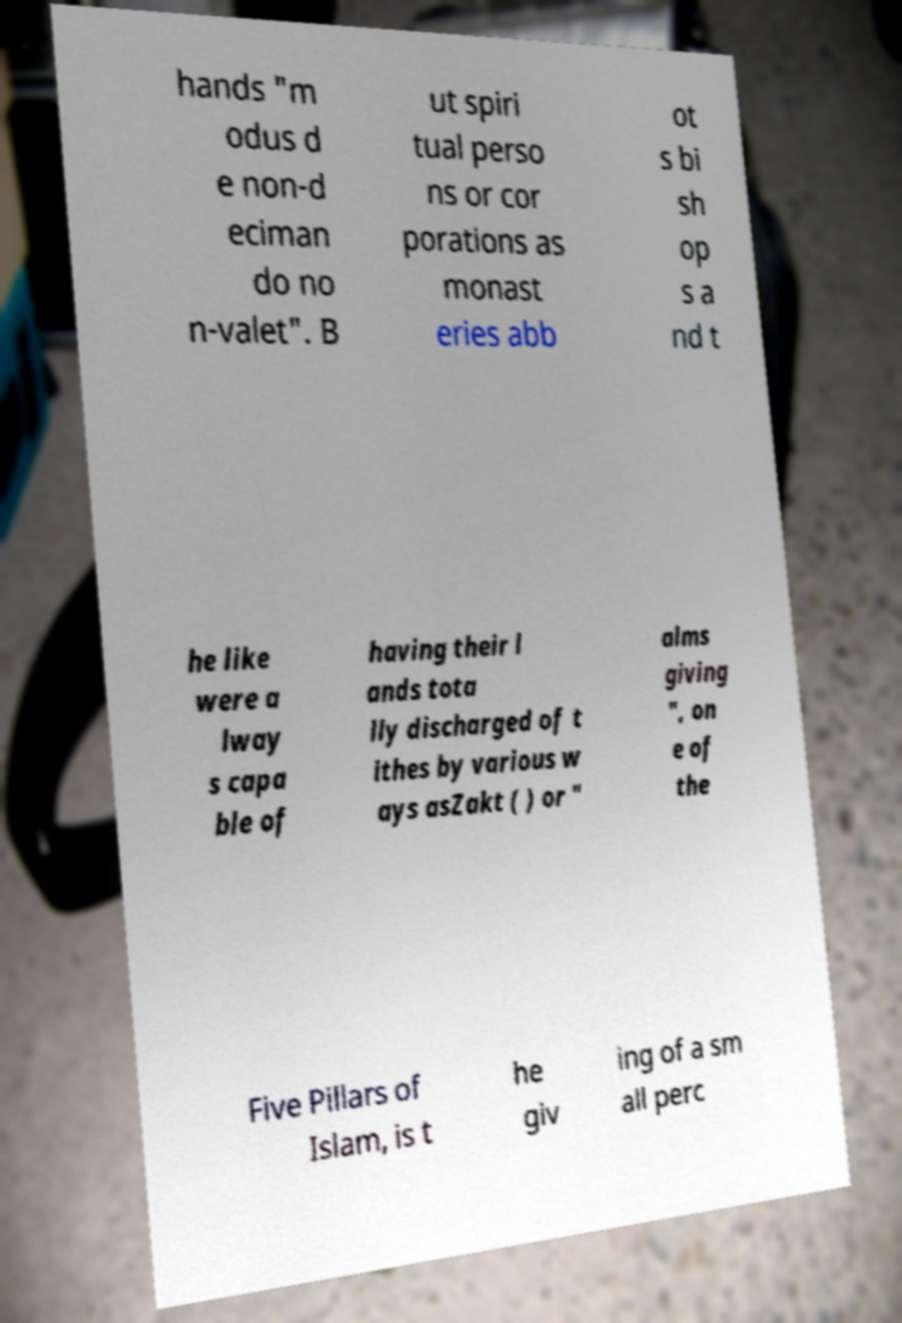Could you extract and type out the text from this image? hands "m odus d e non-d eciman do no n-valet". B ut spiri tual perso ns or cor porations as monast eries abb ot s bi sh op s a nd t he like were a lway s capa ble of having their l ands tota lly discharged of t ithes by various w ays asZakt ( ) or " alms giving ", on e of the Five Pillars of Islam, is t he giv ing of a sm all perc 